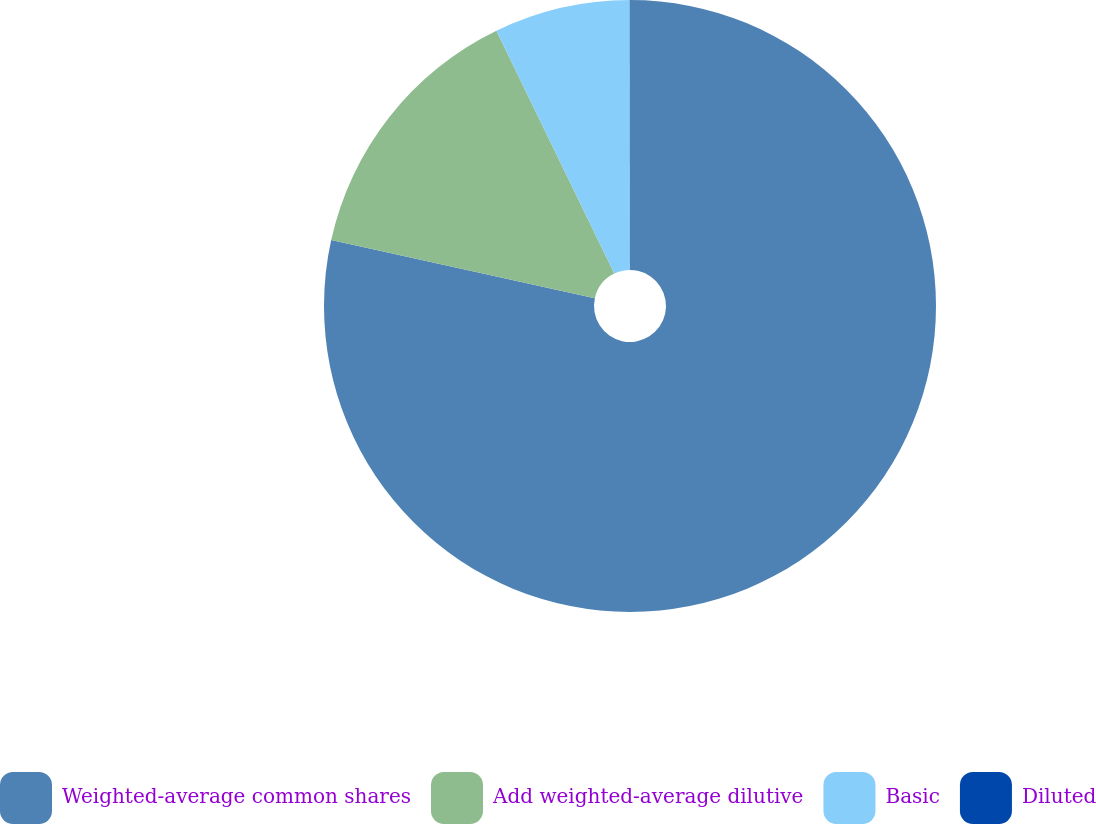Convert chart to OTSL. <chart><loc_0><loc_0><loc_500><loc_500><pie_chart><fcel>Weighted-average common shares<fcel>Add weighted-average dilutive<fcel>Basic<fcel>Diluted<nl><fcel>78.45%<fcel>14.35%<fcel>7.18%<fcel>0.01%<nl></chart> 